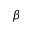Convert formula to latex. <formula><loc_0><loc_0><loc_500><loc_500>\beta</formula> 